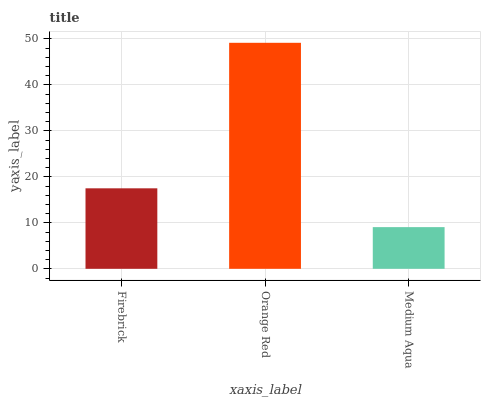Is Medium Aqua the minimum?
Answer yes or no. Yes. Is Orange Red the maximum?
Answer yes or no. Yes. Is Orange Red the minimum?
Answer yes or no. No. Is Medium Aqua the maximum?
Answer yes or no. No. Is Orange Red greater than Medium Aqua?
Answer yes or no. Yes. Is Medium Aqua less than Orange Red?
Answer yes or no. Yes. Is Medium Aqua greater than Orange Red?
Answer yes or no. No. Is Orange Red less than Medium Aqua?
Answer yes or no. No. Is Firebrick the high median?
Answer yes or no. Yes. Is Firebrick the low median?
Answer yes or no. Yes. Is Orange Red the high median?
Answer yes or no. No. Is Orange Red the low median?
Answer yes or no. No. 